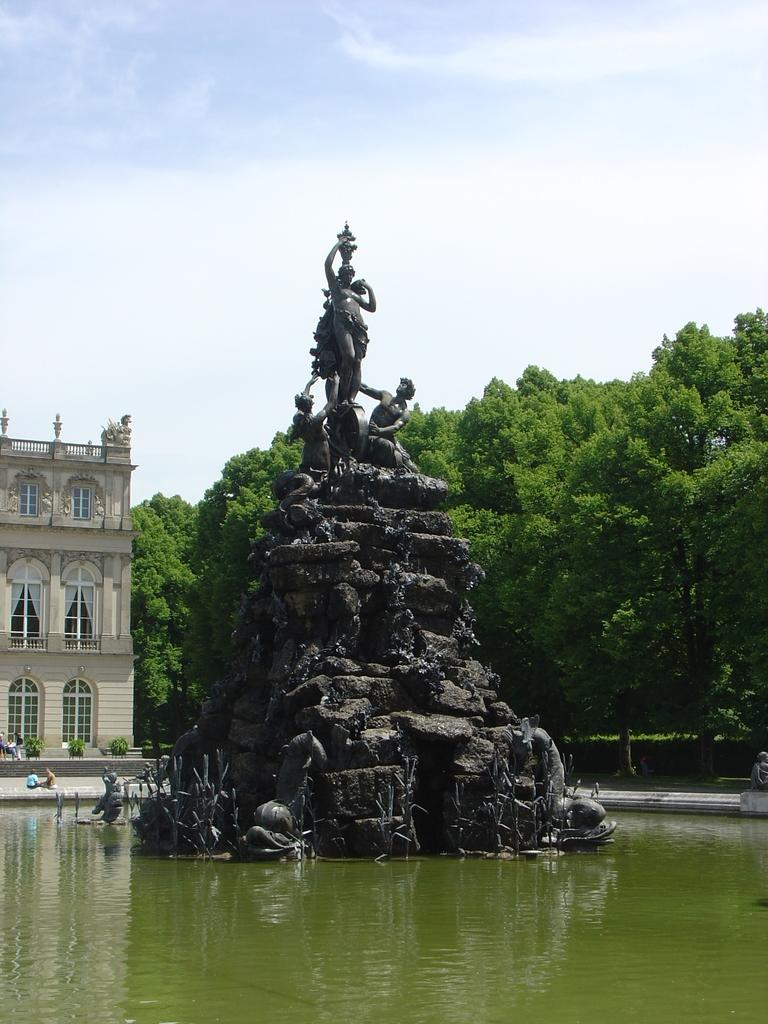What is the main subject in the image? There is a statue in the image. What other structures or elements can be seen in the image? There is a building, trees, stairs, and water visible in the image. Can you describe the building in the image? The building has windows. How many colors are visible in the sky in the image? The sky is blue and white in color. Where is the coal mine located in the image? There is no coal mine present in the image. What type of slope can be seen in the image? There is no slope visible in the image. 